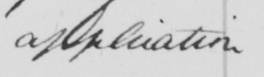Please provide the text content of this handwritten line. application 